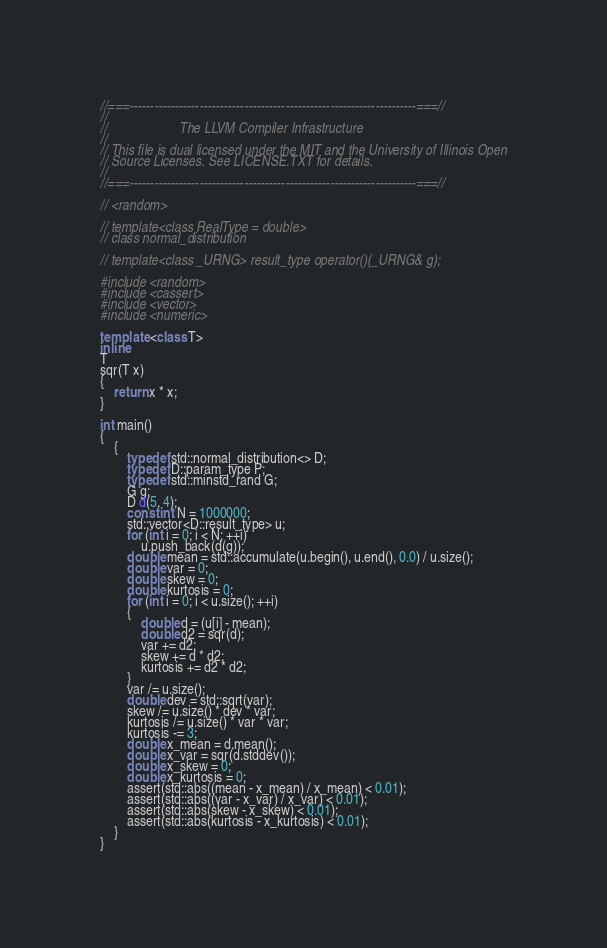<code> <loc_0><loc_0><loc_500><loc_500><_C++_>//===----------------------------------------------------------------------===//
//
//                     The LLVM Compiler Infrastructure
//
// This file is dual licensed under the MIT and the University of Illinois Open
// Source Licenses. See LICENSE.TXT for details.
//
//===----------------------------------------------------------------------===//

// <random>

// template<class RealType = double>
// class normal_distribution

// template<class _URNG> result_type operator()(_URNG& g);

#include <random>
#include <cassert>
#include <vector>
#include <numeric>

template <class T>
inline
T
sqr(T x)
{
    return x * x;
}

int main()
{
    {
        typedef std::normal_distribution<> D;
        typedef D::param_type P;
        typedef std::minstd_rand G;
        G g;
        D d(5, 4);
        const int N = 1000000;
        std::vector<D::result_type> u;
        for (int i = 0; i < N; ++i)
            u.push_back(d(g));
        double mean = std::accumulate(u.begin(), u.end(), 0.0) / u.size();
        double var = 0;
        double skew = 0;
        double kurtosis = 0;
        for (int i = 0; i < u.size(); ++i)
        {
            double d = (u[i] - mean);
            double d2 = sqr(d);
            var += d2;
            skew += d * d2;
            kurtosis += d2 * d2;
        }
        var /= u.size();
        double dev = std::sqrt(var);
        skew /= u.size() * dev * var;
        kurtosis /= u.size() * var * var;
        kurtosis -= 3;
        double x_mean = d.mean();
        double x_var = sqr(d.stddev());
        double x_skew = 0;
        double x_kurtosis = 0;
        assert(std::abs((mean - x_mean) / x_mean) < 0.01);
        assert(std::abs((var - x_var) / x_var) < 0.01);
        assert(std::abs(skew - x_skew) < 0.01);
        assert(std::abs(kurtosis - x_kurtosis) < 0.01);
    }
}
</code> 